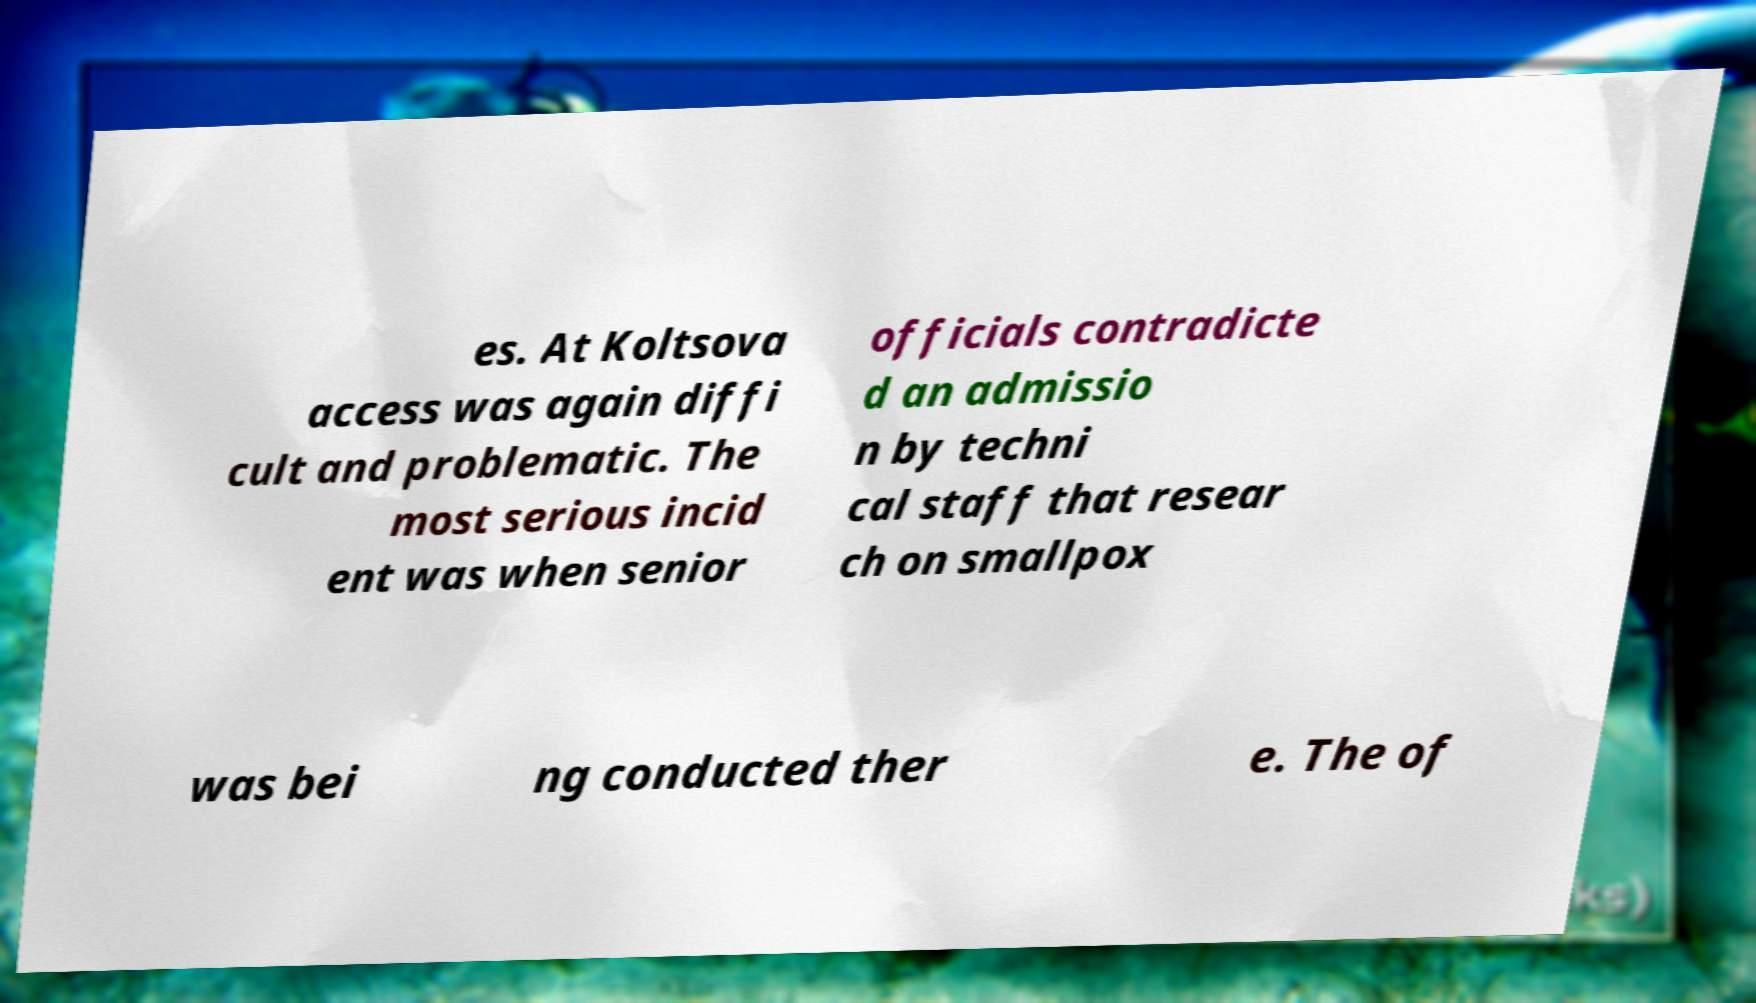Could you assist in decoding the text presented in this image and type it out clearly? es. At Koltsova access was again diffi cult and problematic. The most serious incid ent was when senior officials contradicte d an admissio n by techni cal staff that resear ch on smallpox was bei ng conducted ther e. The of 